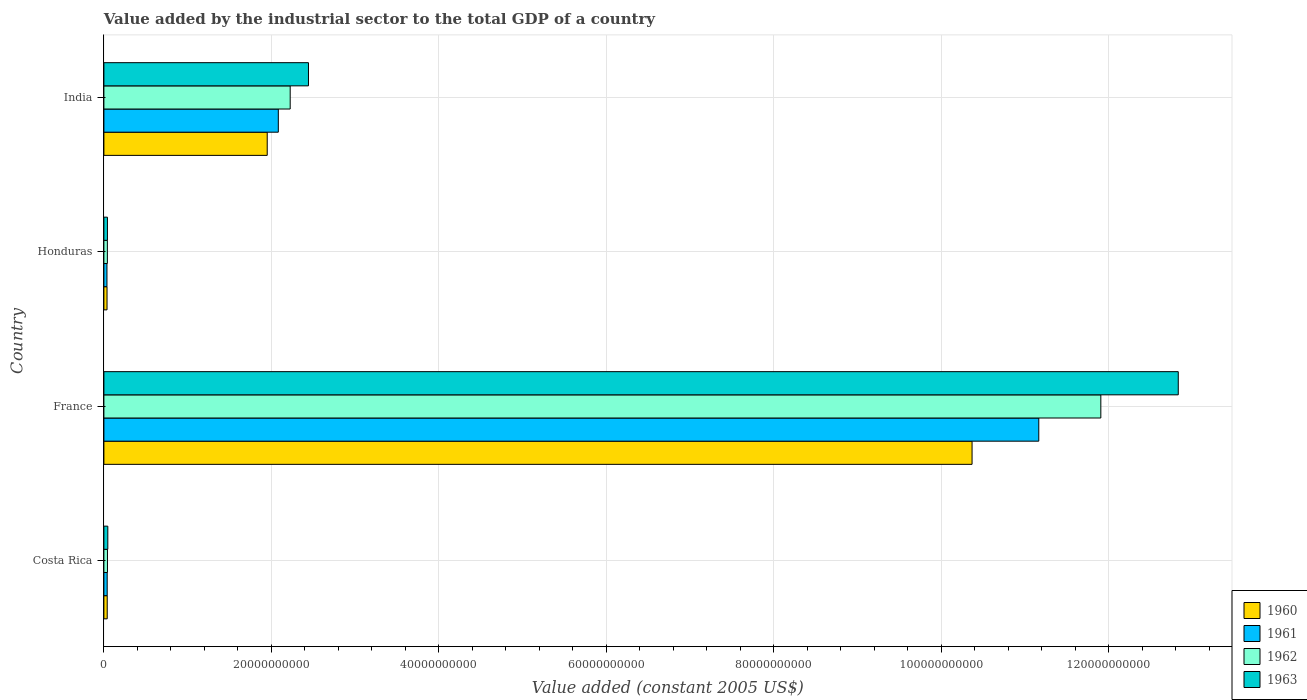How many different coloured bars are there?
Offer a terse response. 4. How many groups of bars are there?
Give a very brief answer. 4. Are the number of bars per tick equal to the number of legend labels?
Ensure brevity in your answer.  Yes. How many bars are there on the 2nd tick from the top?
Your answer should be very brief. 4. In how many cases, is the number of bars for a given country not equal to the number of legend labels?
Give a very brief answer. 0. What is the value added by the industrial sector in 1960 in Honduras?
Provide a succinct answer. 3.75e+08. Across all countries, what is the maximum value added by the industrial sector in 1963?
Make the answer very short. 1.28e+11. Across all countries, what is the minimum value added by the industrial sector in 1962?
Provide a succinct answer. 4.16e+08. In which country was the value added by the industrial sector in 1960 maximum?
Offer a very short reply. France. In which country was the value added by the industrial sector in 1960 minimum?
Your answer should be compact. Honduras. What is the total value added by the industrial sector in 1960 in the graph?
Give a very brief answer. 1.24e+11. What is the difference between the value added by the industrial sector in 1960 in Honduras and that in India?
Provide a short and direct response. -1.91e+1. What is the difference between the value added by the industrial sector in 1962 in France and the value added by the industrial sector in 1963 in Honduras?
Provide a short and direct response. 1.19e+11. What is the average value added by the industrial sector in 1960 per country?
Give a very brief answer. 3.10e+1. What is the difference between the value added by the industrial sector in 1961 and value added by the industrial sector in 1960 in France?
Your answer should be compact. 7.97e+09. What is the ratio of the value added by the industrial sector in 1963 in Costa Rica to that in India?
Your answer should be very brief. 0.02. Is the value added by the industrial sector in 1960 in Costa Rica less than that in France?
Keep it short and to the point. Yes. Is the difference between the value added by the industrial sector in 1961 in Costa Rica and Honduras greater than the difference between the value added by the industrial sector in 1960 in Costa Rica and Honduras?
Provide a short and direct response. Yes. What is the difference between the highest and the second highest value added by the industrial sector in 1961?
Provide a succinct answer. 9.08e+1. What is the difference between the highest and the lowest value added by the industrial sector in 1960?
Give a very brief answer. 1.03e+11. In how many countries, is the value added by the industrial sector in 1962 greater than the average value added by the industrial sector in 1962 taken over all countries?
Your response must be concise. 1. Is the sum of the value added by the industrial sector in 1961 in Costa Rica and France greater than the maximum value added by the industrial sector in 1963 across all countries?
Ensure brevity in your answer.  No. What does the 2nd bar from the top in Honduras represents?
Your answer should be very brief. 1962. What does the 4th bar from the bottom in Honduras represents?
Ensure brevity in your answer.  1963. Is it the case that in every country, the sum of the value added by the industrial sector in 1961 and value added by the industrial sector in 1960 is greater than the value added by the industrial sector in 1963?
Provide a succinct answer. Yes. Are all the bars in the graph horizontal?
Offer a very short reply. Yes. How many countries are there in the graph?
Make the answer very short. 4. Are the values on the major ticks of X-axis written in scientific E-notation?
Your answer should be compact. No. Does the graph contain grids?
Offer a terse response. Yes. Where does the legend appear in the graph?
Give a very brief answer. Bottom right. How are the legend labels stacked?
Ensure brevity in your answer.  Vertical. What is the title of the graph?
Keep it short and to the point. Value added by the industrial sector to the total GDP of a country. What is the label or title of the X-axis?
Ensure brevity in your answer.  Value added (constant 2005 US$). What is the label or title of the Y-axis?
Provide a succinct answer. Country. What is the Value added (constant 2005 US$) in 1960 in Costa Rica?
Give a very brief answer. 3.98e+08. What is the Value added (constant 2005 US$) in 1961 in Costa Rica?
Provide a succinct answer. 3.94e+08. What is the Value added (constant 2005 US$) of 1962 in Costa Rica?
Offer a very short reply. 4.27e+08. What is the Value added (constant 2005 US$) in 1963 in Costa Rica?
Provide a short and direct response. 4.68e+08. What is the Value added (constant 2005 US$) in 1960 in France?
Ensure brevity in your answer.  1.04e+11. What is the Value added (constant 2005 US$) in 1961 in France?
Offer a terse response. 1.12e+11. What is the Value added (constant 2005 US$) of 1962 in France?
Offer a very short reply. 1.19e+11. What is the Value added (constant 2005 US$) in 1963 in France?
Give a very brief answer. 1.28e+11. What is the Value added (constant 2005 US$) of 1960 in Honduras?
Keep it short and to the point. 3.75e+08. What is the Value added (constant 2005 US$) of 1961 in Honduras?
Make the answer very short. 3.66e+08. What is the Value added (constant 2005 US$) in 1962 in Honduras?
Your answer should be very brief. 4.16e+08. What is the Value added (constant 2005 US$) of 1963 in Honduras?
Provide a short and direct response. 4.23e+08. What is the Value added (constant 2005 US$) of 1960 in India?
Offer a terse response. 1.95e+1. What is the Value added (constant 2005 US$) of 1961 in India?
Your answer should be very brief. 2.08e+1. What is the Value added (constant 2005 US$) in 1962 in India?
Offer a very short reply. 2.22e+1. What is the Value added (constant 2005 US$) in 1963 in India?
Offer a very short reply. 2.44e+1. Across all countries, what is the maximum Value added (constant 2005 US$) in 1960?
Keep it short and to the point. 1.04e+11. Across all countries, what is the maximum Value added (constant 2005 US$) in 1961?
Your answer should be compact. 1.12e+11. Across all countries, what is the maximum Value added (constant 2005 US$) of 1962?
Your answer should be compact. 1.19e+11. Across all countries, what is the maximum Value added (constant 2005 US$) of 1963?
Keep it short and to the point. 1.28e+11. Across all countries, what is the minimum Value added (constant 2005 US$) of 1960?
Give a very brief answer. 3.75e+08. Across all countries, what is the minimum Value added (constant 2005 US$) of 1961?
Offer a very short reply. 3.66e+08. Across all countries, what is the minimum Value added (constant 2005 US$) of 1962?
Your answer should be compact. 4.16e+08. Across all countries, what is the minimum Value added (constant 2005 US$) of 1963?
Keep it short and to the point. 4.23e+08. What is the total Value added (constant 2005 US$) of 1960 in the graph?
Give a very brief answer. 1.24e+11. What is the total Value added (constant 2005 US$) in 1961 in the graph?
Offer a terse response. 1.33e+11. What is the total Value added (constant 2005 US$) in 1962 in the graph?
Offer a very short reply. 1.42e+11. What is the total Value added (constant 2005 US$) in 1963 in the graph?
Offer a very short reply. 1.54e+11. What is the difference between the Value added (constant 2005 US$) in 1960 in Costa Rica and that in France?
Offer a very short reply. -1.03e+11. What is the difference between the Value added (constant 2005 US$) of 1961 in Costa Rica and that in France?
Ensure brevity in your answer.  -1.11e+11. What is the difference between the Value added (constant 2005 US$) in 1962 in Costa Rica and that in France?
Offer a terse response. -1.19e+11. What is the difference between the Value added (constant 2005 US$) of 1963 in Costa Rica and that in France?
Your response must be concise. -1.28e+11. What is the difference between the Value added (constant 2005 US$) of 1960 in Costa Rica and that in Honduras?
Give a very brief answer. 2.26e+07. What is the difference between the Value added (constant 2005 US$) of 1961 in Costa Rica and that in Honduras?
Your answer should be very brief. 2.78e+07. What is the difference between the Value added (constant 2005 US$) in 1962 in Costa Rica and that in Honduras?
Make the answer very short. 1.10e+07. What is the difference between the Value added (constant 2005 US$) in 1963 in Costa Rica and that in Honduras?
Your response must be concise. 4.49e+07. What is the difference between the Value added (constant 2005 US$) in 1960 in Costa Rica and that in India?
Provide a short and direct response. -1.91e+1. What is the difference between the Value added (constant 2005 US$) in 1961 in Costa Rica and that in India?
Provide a succinct answer. -2.04e+1. What is the difference between the Value added (constant 2005 US$) of 1962 in Costa Rica and that in India?
Provide a short and direct response. -2.18e+1. What is the difference between the Value added (constant 2005 US$) in 1963 in Costa Rica and that in India?
Provide a short and direct response. -2.40e+1. What is the difference between the Value added (constant 2005 US$) of 1960 in France and that in Honduras?
Give a very brief answer. 1.03e+11. What is the difference between the Value added (constant 2005 US$) of 1961 in France and that in Honduras?
Offer a terse response. 1.11e+11. What is the difference between the Value added (constant 2005 US$) of 1962 in France and that in Honduras?
Offer a terse response. 1.19e+11. What is the difference between the Value added (constant 2005 US$) in 1963 in France and that in Honduras?
Make the answer very short. 1.28e+11. What is the difference between the Value added (constant 2005 US$) in 1960 in France and that in India?
Offer a terse response. 8.42e+1. What is the difference between the Value added (constant 2005 US$) in 1961 in France and that in India?
Provide a succinct answer. 9.08e+1. What is the difference between the Value added (constant 2005 US$) of 1962 in France and that in India?
Keep it short and to the point. 9.68e+1. What is the difference between the Value added (constant 2005 US$) in 1963 in France and that in India?
Your response must be concise. 1.04e+11. What is the difference between the Value added (constant 2005 US$) of 1960 in Honduras and that in India?
Your answer should be very brief. -1.91e+1. What is the difference between the Value added (constant 2005 US$) in 1961 in Honduras and that in India?
Offer a terse response. -2.05e+1. What is the difference between the Value added (constant 2005 US$) in 1962 in Honduras and that in India?
Provide a succinct answer. -2.18e+1. What is the difference between the Value added (constant 2005 US$) of 1963 in Honduras and that in India?
Offer a very short reply. -2.40e+1. What is the difference between the Value added (constant 2005 US$) of 1960 in Costa Rica and the Value added (constant 2005 US$) of 1961 in France?
Your answer should be compact. -1.11e+11. What is the difference between the Value added (constant 2005 US$) of 1960 in Costa Rica and the Value added (constant 2005 US$) of 1962 in France?
Give a very brief answer. -1.19e+11. What is the difference between the Value added (constant 2005 US$) of 1960 in Costa Rica and the Value added (constant 2005 US$) of 1963 in France?
Ensure brevity in your answer.  -1.28e+11. What is the difference between the Value added (constant 2005 US$) of 1961 in Costa Rica and the Value added (constant 2005 US$) of 1962 in France?
Make the answer very short. -1.19e+11. What is the difference between the Value added (constant 2005 US$) of 1961 in Costa Rica and the Value added (constant 2005 US$) of 1963 in France?
Your answer should be compact. -1.28e+11. What is the difference between the Value added (constant 2005 US$) of 1962 in Costa Rica and the Value added (constant 2005 US$) of 1963 in France?
Your response must be concise. -1.28e+11. What is the difference between the Value added (constant 2005 US$) in 1960 in Costa Rica and the Value added (constant 2005 US$) in 1961 in Honduras?
Your response must be concise. 3.20e+07. What is the difference between the Value added (constant 2005 US$) of 1960 in Costa Rica and the Value added (constant 2005 US$) of 1962 in Honduras?
Ensure brevity in your answer.  -1.81e+07. What is the difference between the Value added (constant 2005 US$) in 1960 in Costa Rica and the Value added (constant 2005 US$) in 1963 in Honduras?
Your answer should be very brief. -2.52e+07. What is the difference between the Value added (constant 2005 US$) of 1961 in Costa Rica and the Value added (constant 2005 US$) of 1962 in Honduras?
Ensure brevity in your answer.  -2.22e+07. What is the difference between the Value added (constant 2005 US$) of 1961 in Costa Rica and the Value added (constant 2005 US$) of 1963 in Honduras?
Ensure brevity in your answer.  -2.94e+07. What is the difference between the Value added (constant 2005 US$) of 1962 in Costa Rica and the Value added (constant 2005 US$) of 1963 in Honduras?
Provide a succinct answer. 3.81e+06. What is the difference between the Value added (constant 2005 US$) of 1960 in Costa Rica and the Value added (constant 2005 US$) of 1961 in India?
Make the answer very short. -2.04e+1. What is the difference between the Value added (constant 2005 US$) of 1960 in Costa Rica and the Value added (constant 2005 US$) of 1962 in India?
Give a very brief answer. -2.18e+1. What is the difference between the Value added (constant 2005 US$) of 1960 in Costa Rica and the Value added (constant 2005 US$) of 1963 in India?
Offer a very short reply. -2.40e+1. What is the difference between the Value added (constant 2005 US$) in 1961 in Costa Rica and the Value added (constant 2005 US$) in 1962 in India?
Your answer should be very brief. -2.19e+1. What is the difference between the Value added (constant 2005 US$) in 1961 in Costa Rica and the Value added (constant 2005 US$) in 1963 in India?
Offer a terse response. -2.40e+1. What is the difference between the Value added (constant 2005 US$) in 1962 in Costa Rica and the Value added (constant 2005 US$) in 1963 in India?
Make the answer very short. -2.40e+1. What is the difference between the Value added (constant 2005 US$) in 1960 in France and the Value added (constant 2005 US$) in 1961 in Honduras?
Provide a succinct answer. 1.03e+11. What is the difference between the Value added (constant 2005 US$) in 1960 in France and the Value added (constant 2005 US$) in 1962 in Honduras?
Keep it short and to the point. 1.03e+11. What is the difference between the Value added (constant 2005 US$) in 1960 in France and the Value added (constant 2005 US$) in 1963 in Honduras?
Your answer should be compact. 1.03e+11. What is the difference between the Value added (constant 2005 US$) in 1961 in France and the Value added (constant 2005 US$) in 1962 in Honduras?
Provide a short and direct response. 1.11e+11. What is the difference between the Value added (constant 2005 US$) of 1961 in France and the Value added (constant 2005 US$) of 1963 in Honduras?
Your answer should be compact. 1.11e+11. What is the difference between the Value added (constant 2005 US$) in 1962 in France and the Value added (constant 2005 US$) in 1963 in Honduras?
Give a very brief answer. 1.19e+11. What is the difference between the Value added (constant 2005 US$) in 1960 in France and the Value added (constant 2005 US$) in 1961 in India?
Ensure brevity in your answer.  8.28e+1. What is the difference between the Value added (constant 2005 US$) of 1960 in France and the Value added (constant 2005 US$) of 1962 in India?
Your answer should be very brief. 8.14e+1. What is the difference between the Value added (constant 2005 US$) of 1960 in France and the Value added (constant 2005 US$) of 1963 in India?
Offer a terse response. 7.92e+1. What is the difference between the Value added (constant 2005 US$) in 1961 in France and the Value added (constant 2005 US$) in 1962 in India?
Your answer should be compact. 8.94e+1. What is the difference between the Value added (constant 2005 US$) in 1961 in France and the Value added (constant 2005 US$) in 1963 in India?
Ensure brevity in your answer.  8.72e+1. What is the difference between the Value added (constant 2005 US$) of 1962 in France and the Value added (constant 2005 US$) of 1963 in India?
Provide a short and direct response. 9.46e+1. What is the difference between the Value added (constant 2005 US$) in 1960 in Honduras and the Value added (constant 2005 US$) in 1961 in India?
Offer a very short reply. -2.05e+1. What is the difference between the Value added (constant 2005 US$) in 1960 in Honduras and the Value added (constant 2005 US$) in 1962 in India?
Your answer should be compact. -2.19e+1. What is the difference between the Value added (constant 2005 US$) of 1960 in Honduras and the Value added (constant 2005 US$) of 1963 in India?
Offer a terse response. -2.41e+1. What is the difference between the Value added (constant 2005 US$) in 1961 in Honduras and the Value added (constant 2005 US$) in 1962 in India?
Provide a short and direct response. -2.19e+1. What is the difference between the Value added (constant 2005 US$) in 1961 in Honduras and the Value added (constant 2005 US$) in 1963 in India?
Offer a terse response. -2.41e+1. What is the difference between the Value added (constant 2005 US$) in 1962 in Honduras and the Value added (constant 2005 US$) in 1963 in India?
Offer a terse response. -2.40e+1. What is the average Value added (constant 2005 US$) in 1960 per country?
Offer a terse response. 3.10e+1. What is the average Value added (constant 2005 US$) in 1961 per country?
Offer a terse response. 3.33e+1. What is the average Value added (constant 2005 US$) in 1962 per country?
Give a very brief answer. 3.55e+1. What is the average Value added (constant 2005 US$) in 1963 per country?
Offer a terse response. 3.84e+1. What is the difference between the Value added (constant 2005 US$) in 1960 and Value added (constant 2005 US$) in 1961 in Costa Rica?
Offer a terse response. 4.19e+06. What is the difference between the Value added (constant 2005 US$) in 1960 and Value added (constant 2005 US$) in 1962 in Costa Rica?
Your response must be concise. -2.91e+07. What is the difference between the Value added (constant 2005 US$) in 1960 and Value added (constant 2005 US$) in 1963 in Costa Rica?
Offer a very short reply. -7.01e+07. What is the difference between the Value added (constant 2005 US$) in 1961 and Value added (constant 2005 US$) in 1962 in Costa Rica?
Your answer should be compact. -3.32e+07. What is the difference between the Value added (constant 2005 US$) of 1961 and Value added (constant 2005 US$) of 1963 in Costa Rica?
Offer a very short reply. -7.43e+07. What is the difference between the Value added (constant 2005 US$) in 1962 and Value added (constant 2005 US$) in 1963 in Costa Rica?
Your answer should be compact. -4.11e+07. What is the difference between the Value added (constant 2005 US$) in 1960 and Value added (constant 2005 US$) in 1961 in France?
Offer a terse response. -7.97e+09. What is the difference between the Value added (constant 2005 US$) of 1960 and Value added (constant 2005 US$) of 1962 in France?
Your answer should be compact. -1.54e+1. What is the difference between the Value added (constant 2005 US$) in 1960 and Value added (constant 2005 US$) in 1963 in France?
Offer a very short reply. -2.46e+1. What is the difference between the Value added (constant 2005 US$) in 1961 and Value added (constant 2005 US$) in 1962 in France?
Provide a succinct answer. -7.41e+09. What is the difference between the Value added (constant 2005 US$) of 1961 and Value added (constant 2005 US$) of 1963 in France?
Make the answer very short. -1.67e+1. What is the difference between the Value added (constant 2005 US$) in 1962 and Value added (constant 2005 US$) in 1963 in France?
Your answer should be very brief. -9.25e+09. What is the difference between the Value added (constant 2005 US$) of 1960 and Value added (constant 2005 US$) of 1961 in Honduras?
Make the answer very short. 9.37e+06. What is the difference between the Value added (constant 2005 US$) in 1960 and Value added (constant 2005 US$) in 1962 in Honduras?
Your response must be concise. -4.07e+07. What is the difference between the Value added (constant 2005 US$) in 1960 and Value added (constant 2005 US$) in 1963 in Honduras?
Provide a succinct answer. -4.79e+07. What is the difference between the Value added (constant 2005 US$) in 1961 and Value added (constant 2005 US$) in 1962 in Honduras?
Your response must be concise. -5.00e+07. What is the difference between the Value added (constant 2005 US$) of 1961 and Value added (constant 2005 US$) of 1963 in Honduras?
Give a very brief answer. -5.72e+07. What is the difference between the Value added (constant 2005 US$) in 1962 and Value added (constant 2005 US$) in 1963 in Honduras?
Give a very brief answer. -7.19e+06. What is the difference between the Value added (constant 2005 US$) of 1960 and Value added (constant 2005 US$) of 1961 in India?
Ensure brevity in your answer.  -1.32e+09. What is the difference between the Value added (constant 2005 US$) in 1960 and Value added (constant 2005 US$) in 1962 in India?
Your answer should be very brief. -2.74e+09. What is the difference between the Value added (constant 2005 US$) of 1960 and Value added (constant 2005 US$) of 1963 in India?
Your response must be concise. -4.92e+09. What is the difference between the Value added (constant 2005 US$) of 1961 and Value added (constant 2005 US$) of 1962 in India?
Provide a short and direct response. -1.42e+09. What is the difference between the Value added (constant 2005 US$) in 1961 and Value added (constant 2005 US$) in 1963 in India?
Ensure brevity in your answer.  -3.60e+09. What is the difference between the Value added (constant 2005 US$) in 1962 and Value added (constant 2005 US$) in 1963 in India?
Provide a succinct answer. -2.18e+09. What is the ratio of the Value added (constant 2005 US$) of 1960 in Costa Rica to that in France?
Make the answer very short. 0. What is the ratio of the Value added (constant 2005 US$) of 1961 in Costa Rica to that in France?
Offer a terse response. 0. What is the ratio of the Value added (constant 2005 US$) of 1962 in Costa Rica to that in France?
Make the answer very short. 0. What is the ratio of the Value added (constant 2005 US$) of 1963 in Costa Rica to that in France?
Offer a terse response. 0. What is the ratio of the Value added (constant 2005 US$) of 1960 in Costa Rica to that in Honduras?
Your answer should be very brief. 1.06. What is the ratio of the Value added (constant 2005 US$) in 1961 in Costa Rica to that in Honduras?
Your response must be concise. 1.08. What is the ratio of the Value added (constant 2005 US$) of 1962 in Costa Rica to that in Honduras?
Provide a succinct answer. 1.03. What is the ratio of the Value added (constant 2005 US$) in 1963 in Costa Rica to that in Honduras?
Provide a succinct answer. 1.11. What is the ratio of the Value added (constant 2005 US$) of 1960 in Costa Rica to that in India?
Keep it short and to the point. 0.02. What is the ratio of the Value added (constant 2005 US$) in 1961 in Costa Rica to that in India?
Offer a very short reply. 0.02. What is the ratio of the Value added (constant 2005 US$) of 1962 in Costa Rica to that in India?
Make the answer very short. 0.02. What is the ratio of the Value added (constant 2005 US$) of 1963 in Costa Rica to that in India?
Your answer should be very brief. 0.02. What is the ratio of the Value added (constant 2005 US$) of 1960 in France to that in Honduras?
Give a very brief answer. 276.31. What is the ratio of the Value added (constant 2005 US$) in 1961 in France to that in Honduras?
Keep it short and to the point. 305.16. What is the ratio of the Value added (constant 2005 US$) in 1962 in France to that in Honduras?
Your response must be concise. 286.26. What is the ratio of the Value added (constant 2005 US$) in 1963 in France to that in Honduras?
Provide a short and direct response. 303.25. What is the ratio of the Value added (constant 2005 US$) in 1960 in France to that in India?
Your response must be concise. 5.32. What is the ratio of the Value added (constant 2005 US$) of 1961 in France to that in India?
Offer a terse response. 5.36. What is the ratio of the Value added (constant 2005 US$) in 1962 in France to that in India?
Provide a succinct answer. 5.35. What is the ratio of the Value added (constant 2005 US$) of 1963 in France to that in India?
Offer a very short reply. 5.25. What is the ratio of the Value added (constant 2005 US$) in 1960 in Honduras to that in India?
Your response must be concise. 0.02. What is the ratio of the Value added (constant 2005 US$) of 1961 in Honduras to that in India?
Your answer should be very brief. 0.02. What is the ratio of the Value added (constant 2005 US$) in 1962 in Honduras to that in India?
Provide a succinct answer. 0.02. What is the ratio of the Value added (constant 2005 US$) in 1963 in Honduras to that in India?
Offer a very short reply. 0.02. What is the difference between the highest and the second highest Value added (constant 2005 US$) in 1960?
Your response must be concise. 8.42e+1. What is the difference between the highest and the second highest Value added (constant 2005 US$) in 1961?
Ensure brevity in your answer.  9.08e+1. What is the difference between the highest and the second highest Value added (constant 2005 US$) of 1962?
Your answer should be compact. 9.68e+1. What is the difference between the highest and the second highest Value added (constant 2005 US$) in 1963?
Make the answer very short. 1.04e+11. What is the difference between the highest and the lowest Value added (constant 2005 US$) in 1960?
Provide a short and direct response. 1.03e+11. What is the difference between the highest and the lowest Value added (constant 2005 US$) in 1961?
Your answer should be compact. 1.11e+11. What is the difference between the highest and the lowest Value added (constant 2005 US$) of 1962?
Provide a succinct answer. 1.19e+11. What is the difference between the highest and the lowest Value added (constant 2005 US$) in 1963?
Your response must be concise. 1.28e+11. 